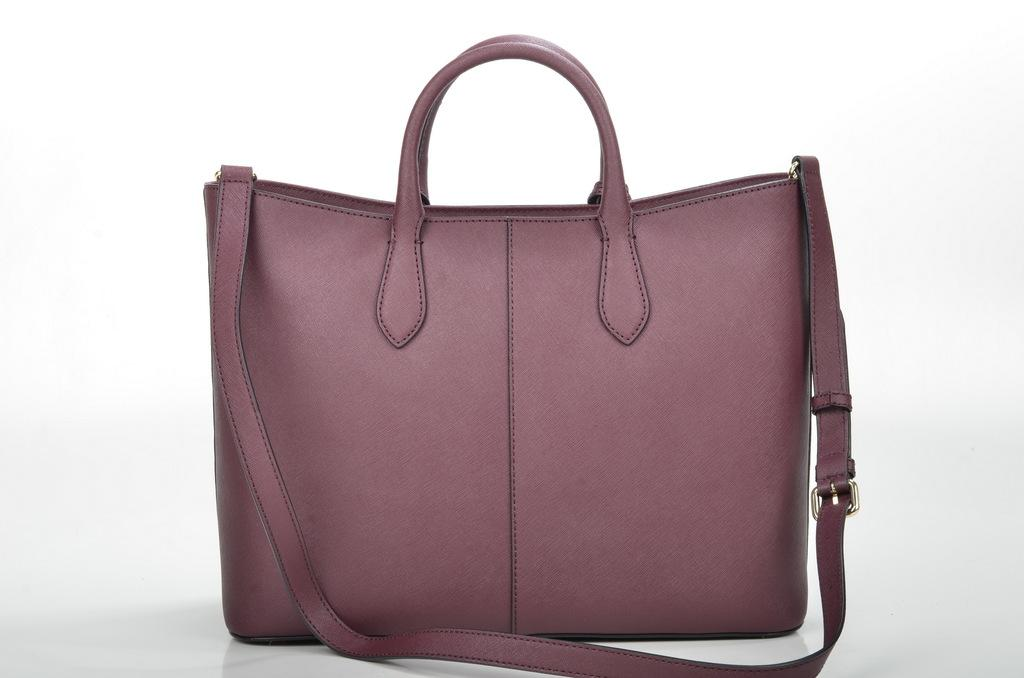What object can be seen in the image? There is a bag in the image. What type of war is depicted in the image? There is no war depicted in the image; it only features a bag. How many eyes can be seen on the bag in the image? There are no eyes present on the bag in the image. 